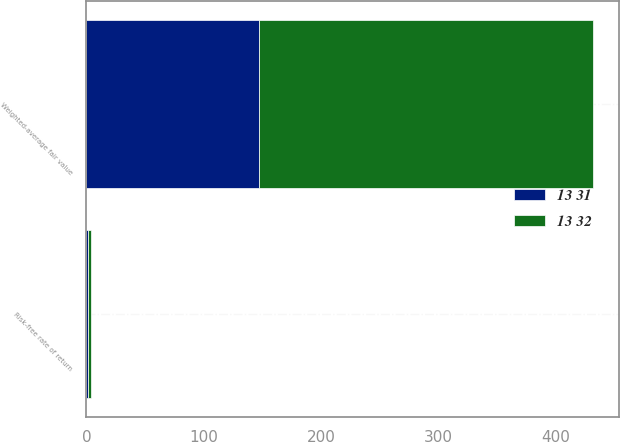Convert chart to OTSL. <chart><loc_0><loc_0><loc_500><loc_500><stacked_bar_chart><ecel><fcel>Risk-free rate of return<fcel>Weighted-average fair value<nl><fcel>13 32<fcel>2.41<fcel>284.78<nl><fcel>13 31<fcel>1.49<fcel>147.25<nl></chart> 